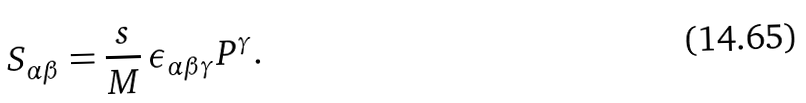<formula> <loc_0><loc_0><loc_500><loc_500>S _ { \alpha \beta } = \frac { s } { M } \, \epsilon _ { \alpha \beta \gamma } P ^ { \gamma } .</formula> 